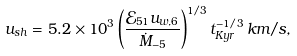Convert formula to latex. <formula><loc_0><loc_0><loc_500><loc_500>u _ { s h } = 5 . 2 \times 1 0 ^ { 3 } \left ( \frac { \mathcal { E } _ { 5 1 } u _ { w , 6 } } { \dot { M } _ { - 5 } } \right ) ^ { 1 / 3 } t _ { K y r } ^ { - 1 / 3 } \, { k m / s , }</formula> 